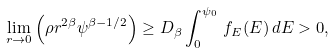Convert formula to latex. <formula><loc_0><loc_0><loc_500><loc_500>\lim _ { r \rightarrow 0 } \left ( \rho r ^ { 2 \beta } \psi ^ { \beta - 1 / 2 } \right ) \geq D _ { \beta } \int _ { 0 } ^ { \psi _ { 0 } } \, f _ { E } ( E ) \, d E > 0 ,</formula> 